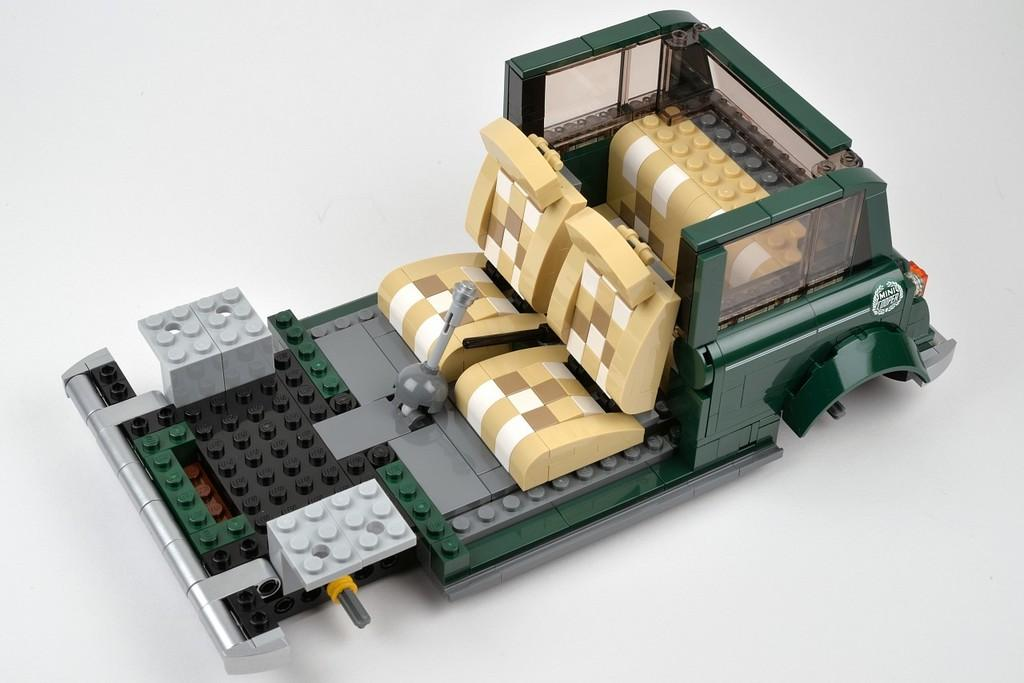What is the main object in the image? There is a toy car in the image. What color is the background of the image? The background of the image is white. How many men are in the image? There are no men present in the image; it features a toy car against a white background. What type of group is depicted in the image? There is no group depicted in the image; it features a toy car against a white background. 